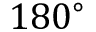<formula> <loc_0><loc_0><loc_500><loc_500>1 8 0 ^ { \circ }</formula> 